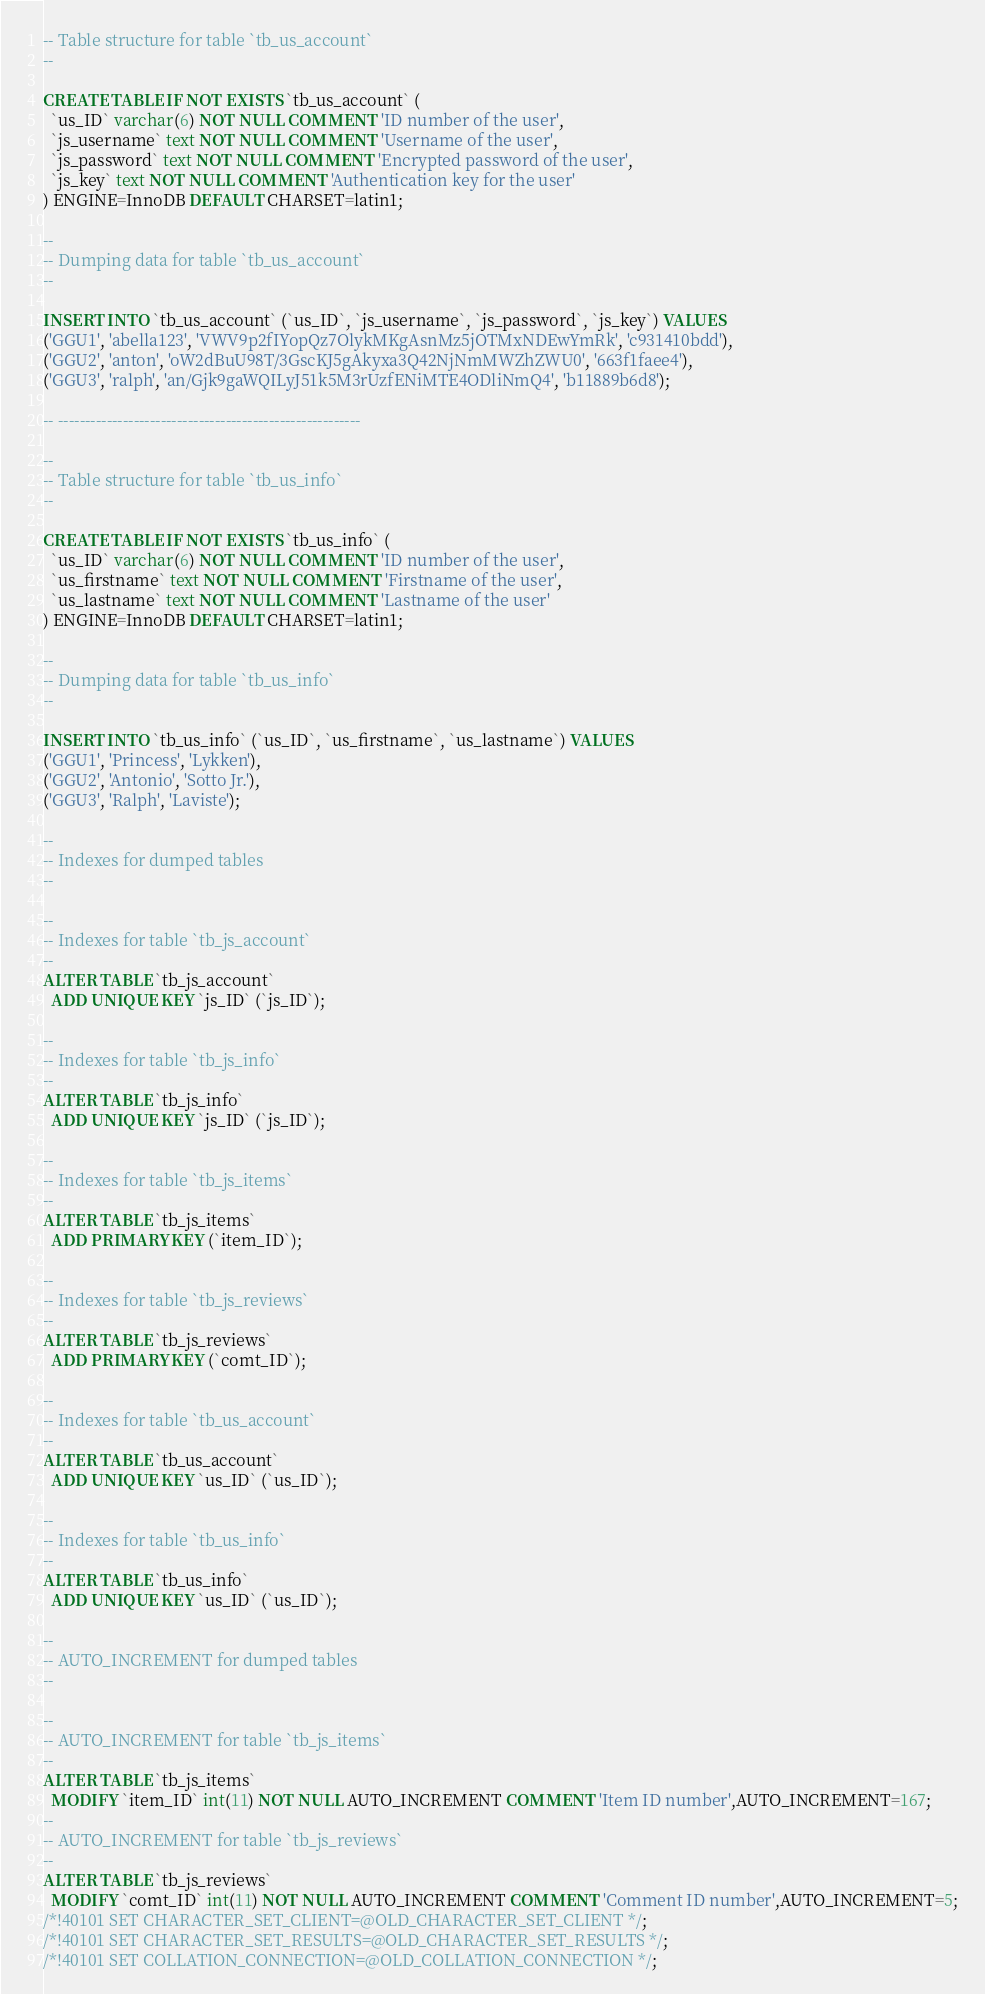Convert code to text. <code><loc_0><loc_0><loc_500><loc_500><_SQL_>-- Table structure for table `tb_us_account`
--

CREATE TABLE IF NOT EXISTS `tb_us_account` (
  `us_ID` varchar(6) NOT NULL COMMENT 'ID number of the user',
  `js_username` text NOT NULL COMMENT 'Username of the user',
  `js_password` text NOT NULL COMMENT 'Encrypted password of the user',
  `js_key` text NOT NULL COMMENT 'Authentication key for the user'
) ENGINE=InnoDB DEFAULT CHARSET=latin1;

--
-- Dumping data for table `tb_us_account`
--

INSERT INTO `tb_us_account` (`us_ID`, `js_username`, `js_password`, `js_key`) VALUES
('GGU1', 'abella123', 'VWV9p2fIYopQz7OlykMKgAsnMz5jOTMxNDEwYmRk', 'c931410bdd'),
('GGU2', 'anton', 'oW2dBuU98T/3GscKJ5gAkyxa3Q42NjNmMWZhZWU0', '663f1faee4'),
('GGU3', 'ralph', 'an/Gjk9gaWQILyJ51k5M3rUzfENiMTE4ODliNmQ4', 'b11889b6d8');

-- --------------------------------------------------------

--
-- Table structure for table `tb_us_info`
--

CREATE TABLE IF NOT EXISTS `tb_us_info` (
  `us_ID` varchar(6) NOT NULL COMMENT 'ID number of the user',
  `us_firstname` text NOT NULL COMMENT 'Firstname of the user',
  `us_lastname` text NOT NULL COMMENT 'Lastname of the user'
) ENGINE=InnoDB DEFAULT CHARSET=latin1;

--
-- Dumping data for table `tb_us_info`
--

INSERT INTO `tb_us_info` (`us_ID`, `us_firstname`, `us_lastname`) VALUES
('GGU1', 'Princess', 'Lykken'),
('GGU2', 'Antonio', 'Sotto Jr.'),
('GGU3', 'Ralph', 'Laviste');

--
-- Indexes for dumped tables
--

--
-- Indexes for table `tb_js_account`
--
ALTER TABLE `tb_js_account`
  ADD UNIQUE KEY `js_ID` (`js_ID`);

--
-- Indexes for table `tb_js_info`
--
ALTER TABLE `tb_js_info`
  ADD UNIQUE KEY `js_ID` (`js_ID`);

--
-- Indexes for table `tb_js_items`
--
ALTER TABLE `tb_js_items`
  ADD PRIMARY KEY (`item_ID`);

--
-- Indexes for table `tb_js_reviews`
--
ALTER TABLE `tb_js_reviews`
  ADD PRIMARY KEY (`comt_ID`);

--
-- Indexes for table `tb_us_account`
--
ALTER TABLE `tb_us_account`
  ADD UNIQUE KEY `us_ID` (`us_ID`);

--
-- Indexes for table `tb_us_info`
--
ALTER TABLE `tb_us_info`
  ADD UNIQUE KEY `us_ID` (`us_ID`);

--
-- AUTO_INCREMENT for dumped tables
--

--
-- AUTO_INCREMENT for table `tb_js_items`
--
ALTER TABLE `tb_js_items`
  MODIFY `item_ID` int(11) NOT NULL AUTO_INCREMENT COMMENT 'Item ID number',AUTO_INCREMENT=167;
--
-- AUTO_INCREMENT for table `tb_js_reviews`
--
ALTER TABLE `tb_js_reviews`
  MODIFY `comt_ID` int(11) NOT NULL AUTO_INCREMENT COMMENT 'Comment ID number',AUTO_INCREMENT=5;
/*!40101 SET CHARACTER_SET_CLIENT=@OLD_CHARACTER_SET_CLIENT */;
/*!40101 SET CHARACTER_SET_RESULTS=@OLD_CHARACTER_SET_RESULTS */;
/*!40101 SET COLLATION_CONNECTION=@OLD_COLLATION_CONNECTION */;
</code> 